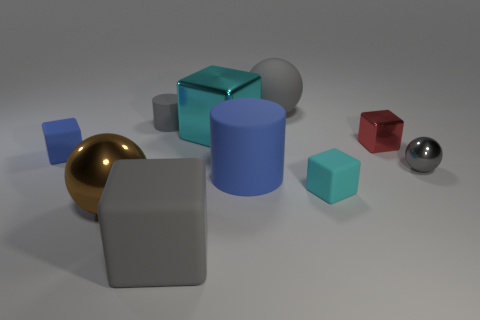How many large objects are gray rubber blocks or metal cubes?
Give a very brief answer. 2. Are there any other things of the same color as the big matte cube?
Give a very brief answer. Yes. What is the shape of the small cyan thing that is the same material as the large cylinder?
Your answer should be very brief. Cube. There is a rubber cylinder that is to the right of the gray rubber cylinder; what is its size?
Your response must be concise. Large. What shape is the cyan metallic thing?
Keep it short and to the point. Cube. There is a rubber cylinder that is to the right of the big cyan shiny object; does it have the same size as the gray thing to the right of the red cube?
Offer a terse response. No. What size is the shiny ball that is on the left side of the shiny ball that is right of the matte cube on the right side of the large metal block?
Make the answer very short. Large. The large shiny thing that is behind the metal sphere on the left side of the small gray object that is on the left side of the matte sphere is what shape?
Offer a terse response. Cube. There is a tiny rubber object left of the small gray matte cylinder; what is its shape?
Your answer should be compact. Cube. Is the material of the brown sphere the same as the tiny thing to the left of the brown thing?
Offer a terse response. No. 